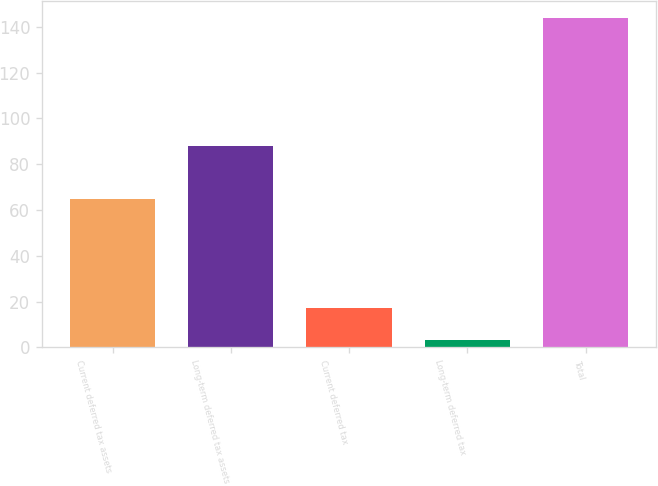Convert chart to OTSL. <chart><loc_0><loc_0><loc_500><loc_500><bar_chart><fcel>Current deferred tax assets<fcel>Long-term deferred tax assets<fcel>Current deferred tax<fcel>Long-term deferred tax<fcel>Total<nl><fcel>65<fcel>88<fcel>17.1<fcel>3<fcel>144<nl></chart> 